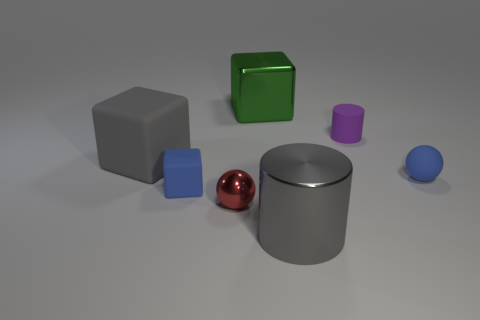Are there any tiny blue matte objects that have the same shape as the small purple object?
Your answer should be very brief. No. Is the material of the small red sphere the same as the ball right of the purple matte cylinder?
Ensure brevity in your answer.  No. What color is the big object left of the sphere to the left of the tiny sphere to the right of the tiny purple thing?
Make the answer very short. Gray. There is a cylinder that is the same size as the green object; what is it made of?
Offer a terse response. Metal. What number of tiny purple cylinders have the same material as the tiny red sphere?
Offer a very short reply. 0. There is a gray cylinder that is to the right of the big green thing; is its size the same as the blue matte object that is on the right side of the metal block?
Make the answer very short. No. What color is the rubber thing behind the gray matte thing?
Your answer should be very brief. Purple. There is a big cube that is the same color as the large cylinder; what material is it?
Offer a very short reply. Rubber. What number of tiny matte balls have the same color as the big metallic cylinder?
Your response must be concise. 0. Do the green shiny thing and the red metal sphere on the left side of the big gray metallic cylinder have the same size?
Make the answer very short. No. 